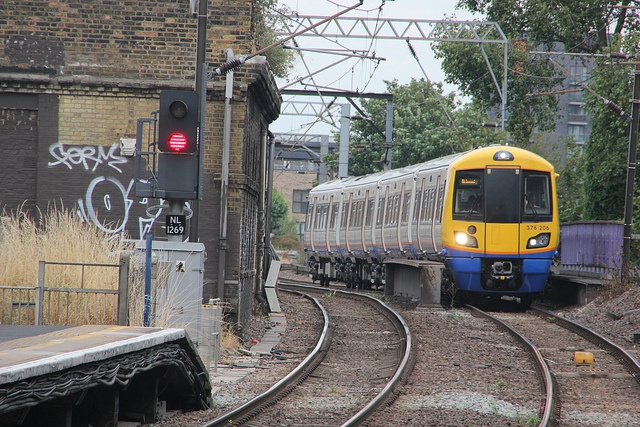Describe the objects in this image and their specific colors. I can see train in brown, black, darkgray, gray, and orange tones, traffic light in brown, black, gray, and maroon tones, people in brown, black, gray, and purple tones, and people in brown, black, and gray tones in this image. 